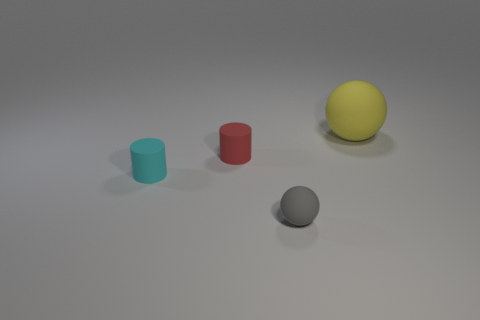There is a sphere in front of the rubber sphere behind the small matte thing that is left of the red cylinder; what is its material?
Provide a succinct answer. Rubber. Are there the same number of tiny red cylinders in front of the cyan rubber cylinder and red things?
Give a very brief answer. No. Is the ball behind the gray ball made of the same material as the ball left of the big yellow rubber object?
Offer a terse response. Yes. Are there any other things that are made of the same material as the small gray sphere?
Your answer should be very brief. Yes. There is a rubber thing right of the gray rubber object; is its shape the same as the object that is to the left of the small red thing?
Your answer should be compact. No. Is the number of large objects in front of the tiny gray matte object less than the number of small red objects?
Offer a terse response. Yes. What number of big rubber spheres have the same color as the large object?
Provide a short and direct response. 0. What is the size of the matte sphere that is behind the cyan matte object?
Ensure brevity in your answer.  Large. What shape is the object to the right of the matte ball that is on the left side of the thing that is on the right side of the small sphere?
Keep it short and to the point. Sphere. There is a small object that is both to the right of the cyan cylinder and behind the gray rubber ball; what is its shape?
Provide a short and direct response. Cylinder. 